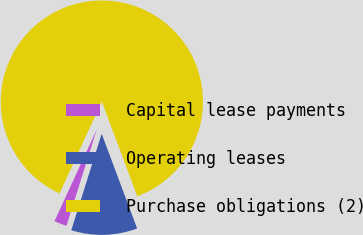<chart> <loc_0><loc_0><loc_500><loc_500><pie_chart><fcel>Capital lease payments<fcel>Operating leases<fcel>Purchase obligations (2)<nl><fcel>2.02%<fcel>10.56%<fcel>87.42%<nl></chart> 